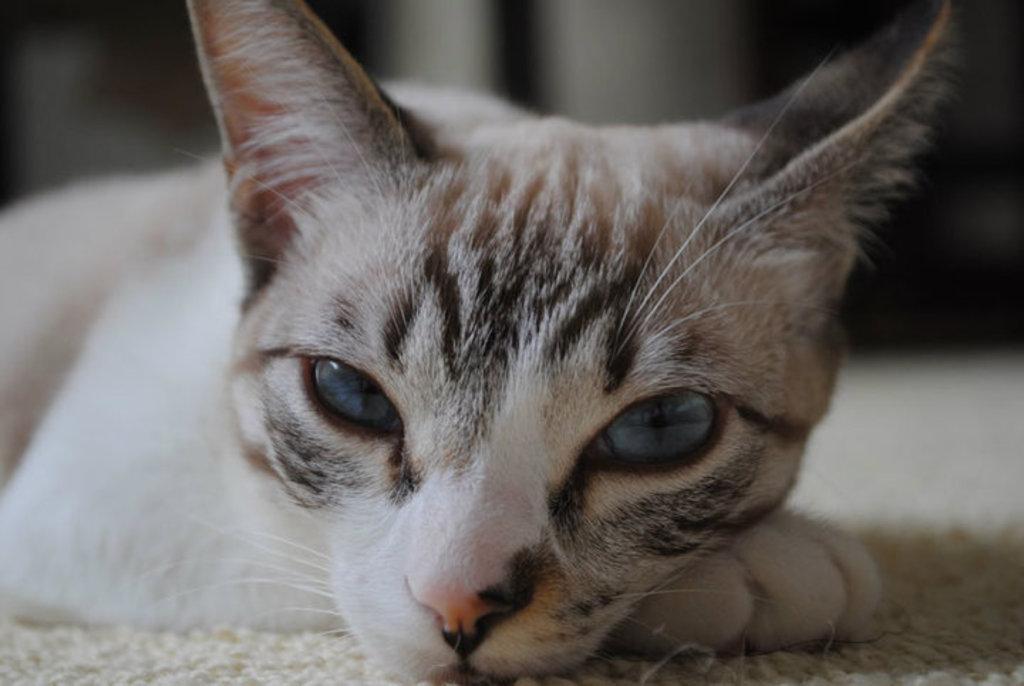What type of animal is in the image? There is a cat in the image. Where is the cat located? The cat is on a mat. What is the cat's brother doing in the image? There is no mention of a brother or any other animals in the image, so we cannot answer this question. 